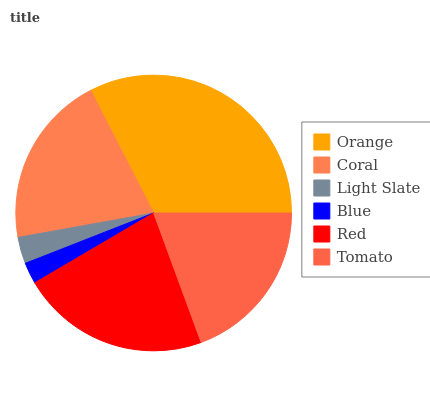Is Blue the minimum?
Answer yes or no. Yes. Is Orange the maximum?
Answer yes or no. Yes. Is Coral the minimum?
Answer yes or no. No. Is Coral the maximum?
Answer yes or no. No. Is Orange greater than Coral?
Answer yes or no. Yes. Is Coral less than Orange?
Answer yes or no. Yes. Is Coral greater than Orange?
Answer yes or no. No. Is Orange less than Coral?
Answer yes or no. No. Is Coral the high median?
Answer yes or no. Yes. Is Tomato the low median?
Answer yes or no. Yes. Is Tomato the high median?
Answer yes or no. No. Is Light Slate the low median?
Answer yes or no. No. 